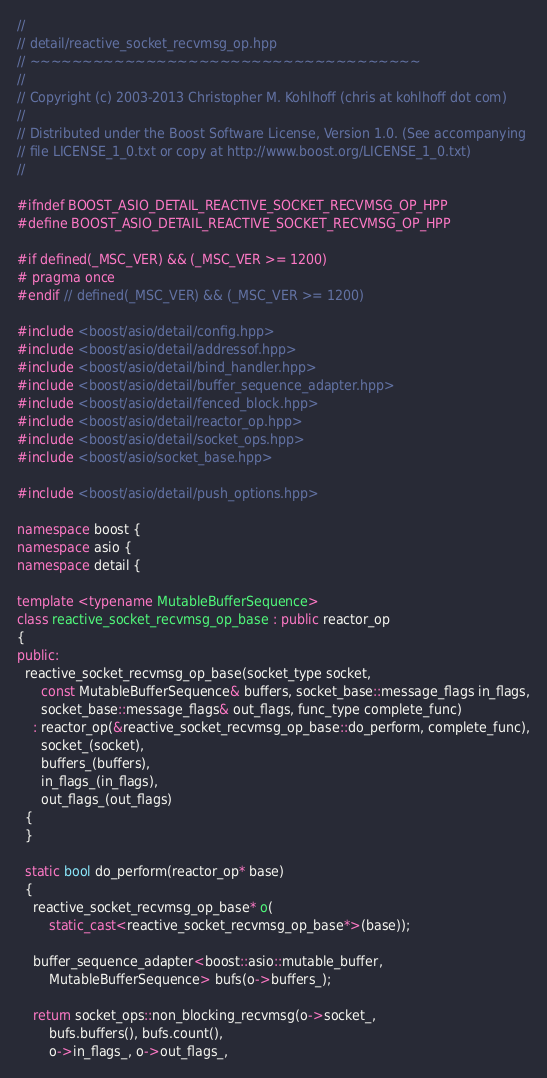Convert code to text. <code><loc_0><loc_0><loc_500><loc_500><_C++_>//
// detail/reactive_socket_recvmsg_op.hpp
// ~~~~~~~~~~~~~~~~~~~~~~~~~~~~~~~~~~~~~
//
// Copyright (c) 2003-2013 Christopher M. Kohlhoff (chris at kohlhoff dot com)
//
// Distributed under the Boost Software License, Version 1.0. (See accompanying
// file LICENSE_1_0.txt or copy at http://www.boost.org/LICENSE_1_0.txt)
//

#ifndef BOOST_ASIO_DETAIL_REACTIVE_SOCKET_RECVMSG_OP_HPP
#define BOOST_ASIO_DETAIL_REACTIVE_SOCKET_RECVMSG_OP_HPP

#if defined(_MSC_VER) && (_MSC_VER >= 1200)
# pragma once
#endif // defined(_MSC_VER) && (_MSC_VER >= 1200)

#include <boost/asio/detail/config.hpp>
#include <boost/asio/detail/addressof.hpp>
#include <boost/asio/detail/bind_handler.hpp>
#include <boost/asio/detail/buffer_sequence_adapter.hpp>
#include <boost/asio/detail/fenced_block.hpp>
#include <boost/asio/detail/reactor_op.hpp>
#include <boost/asio/detail/socket_ops.hpp>
#include <boost/asio/socket_base.hpp>

#include <boost/asio/detail/push_options.hpp>

namespace boost {
namespace asio {
namespace detail {

template <typename MutableBufferSequence>
class reactive_socket_recvmsg_op_base : public reactor_op
{
public:
  reactive_socket_recvmsg_op_base(socket_type socket,
      const MutableBufferSequence& buffers, socket_base::message_flags in_flags,
      socket_base::message_flags& out_flags, func_type complete_func)
    : reactor_op(&reactive_socket_recvmsg_op_base::do_perform, complete_func),
      socket_(socket),
      buffers_(buffers),
      in_flags_(in_flags),
      out_flags_(out_flags)
  {
  }

  static bool do_perform(reactor_op* base)
  {
    reactive_socket_recvmsg_op_base* o(
        static_cast<reactive_socket_recvmsg_op_base*>(base));

    buffer_sequence_adapter<boost::asio::mutable_buffer,
        MutableBufferSequence> bufs(o->buffers_);

    return socket_ops::non_blocking_recvmsg(o->socket_,
        bufs.buffers(), bufs.count(),
        o->in_flags_, o->out_flags_,</code> 